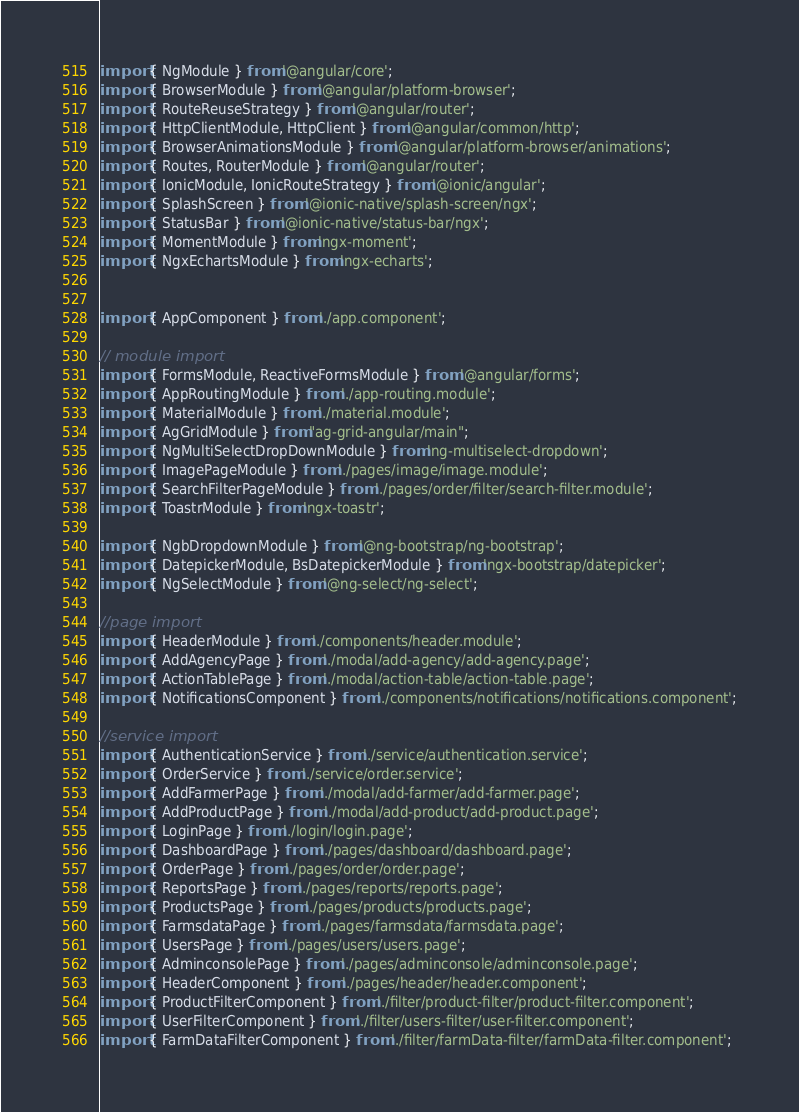<code> <loc_0><loc_0><loc_500><loc_500><_TypeScript_>import { NgModule } from '@angular/core';
import { BrowserModule } from '@angular/platform-browser';
import { RouteReuseStrategy } from '@angular/router';
import { HttpClientModule, HttpClient } from '@angular/common/http';
import { BrowserAnimationsModule } from '@angular/platform-browser/animations';
import { Routes, RouterModule } from '@angular/router';
import { IonicModule, IonicRouteStrategy } from '@ionic/angular';
import { SplashScreen } from '@ionic-native/splash-screen/ngx';
import { StatusBar } from '@ionic-native/status-bar/ngx';
import { MomentModule } from 'ngx-moment';
import { NgxEchartsModule } from 'ngx-echarts';


import { AppComponent } from './app.component';

// module import
import { FormsModule, ReactiveFormsModule } from '@angular/forms';
import { AppRoutingModule } from './app-routing.module';
import { MaterialModule } from './material.module';
import { AgGridModule } from "ag-grid-angular/main";
import { NgMultiSelectDropDownModule } from 'ng-multiselect-dropdown';
import { ImagePageModule } from './pages/image/image.module';
import { SearchFilterPageModule } from './pages/order/filter/search-filter.module';
import { ToastrModule } from 'ngx-toastr';

import { NgbDropdownModule } from '@ng-bootstrap/ng-bootstrap';
import { DatepickerModule, BsDatepickerModule } from 'ngx-bootstrap/datepicker';
import { NgSelectModule } from '@ng-select/ng-select';

//page import
import { HeaderModule } from './components/header.module';
import { AddAgencyPage } from './modal/add-agency/add-agency.page';
import { ActionTablePage } from './modal/action-table/action-table.page';
import { NotificationsComponent } from './components/notifications/notifications.component';

//service import
import { AuthenticationService } from './service/authentication.service';
import { OrderService } from './service/order.service';
import { AddFarmerPage } from './modal/add-farmer/add-farmer.page';
import { AddProductPage } from './modal/add-product/add-product.page';
import { LoginPage } from './login/login.page';
import { DashboardPage } from './pages/dashboard/dashboard.page';
import { OrderPage } from './pages/order/order.page';
import { ReportsPage } from './pages/reports/reports.page';
import { ProductsPage } from './pages/products/products.page';
import { FarmsdataPage } from './pages/farmsdata/farmsdata.page';
import { UsersPage } from './pages/users/users.page';
import { AdminconsolePage } from './pages/adminconsole/adminconsole.page';
import { HeaderComponent } from './pages/header/header.component';
import { ProductFilterComponent } from './filter/product-filter/product-filter.component';
import { UserFilterComponent } from './filter/users-filter/user-filter.component';
import { FarmDataFilterComponent } from './filter/farmData-filter/farmData-filter.component';</code> 